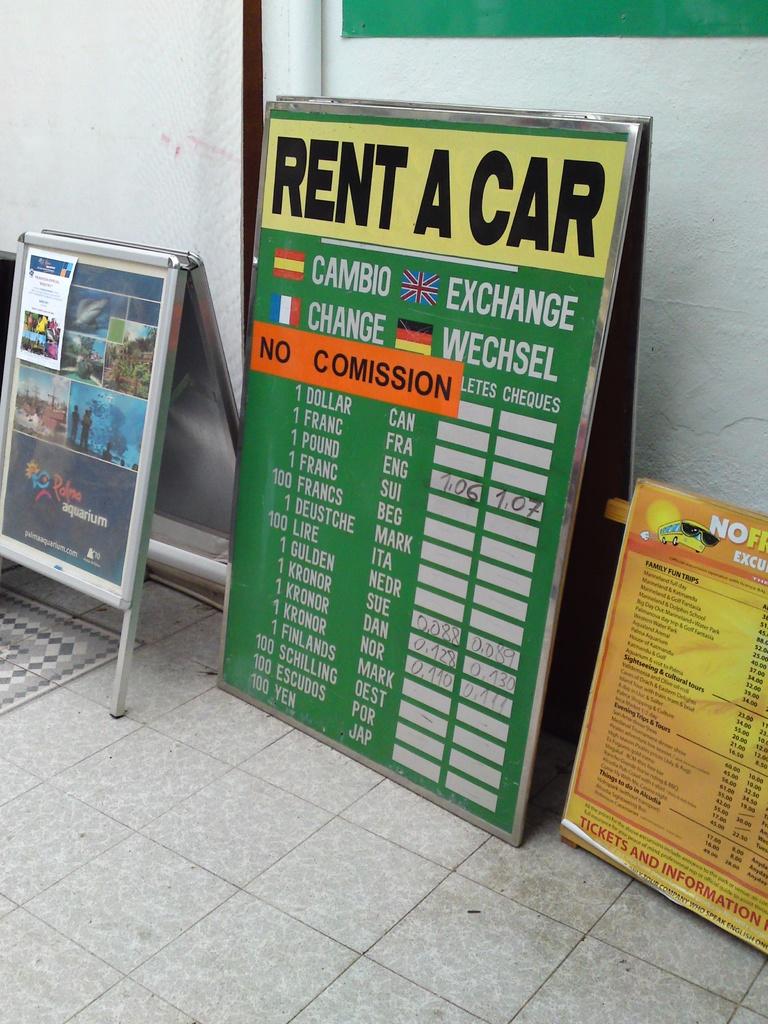What object can you rent here?
Your response must be concise. Car. What does the orange strip say on the sign?
Provide a short and direct response. No comission. 